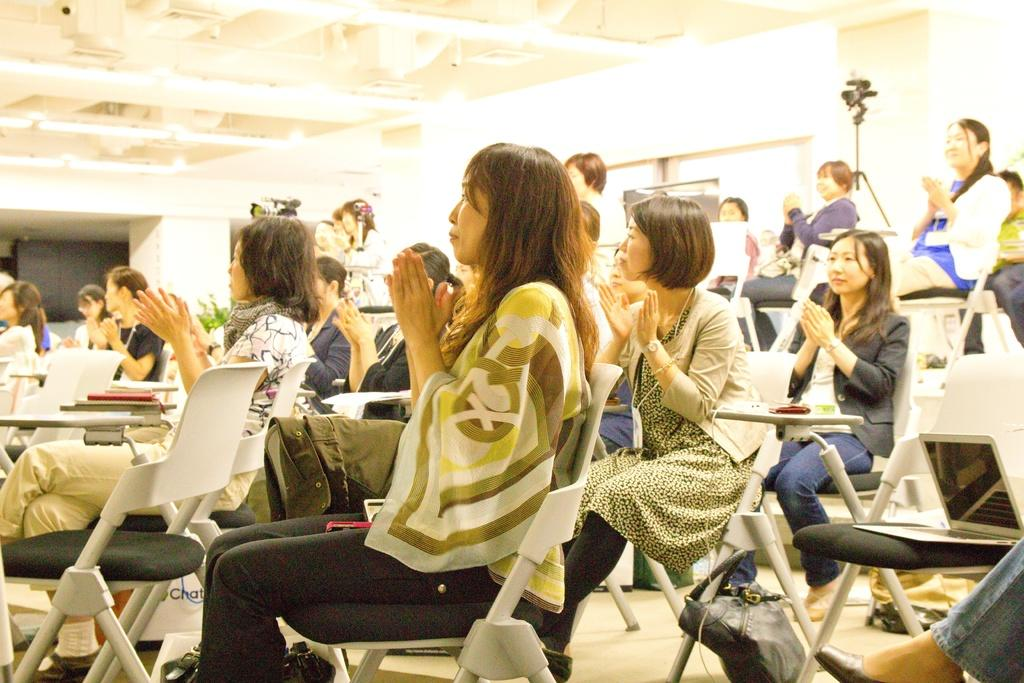What are the women in the image doing? The women are sitting on chairs in the image. What can be seen in the background of the image? There are cameras, plants, and a laptop in the background of the image. What type of mountain can be seen in the image? There is no mountain present in the image. What game are the women playing in the image? The women are not playing a game in the image; they are sitting on chairs. 